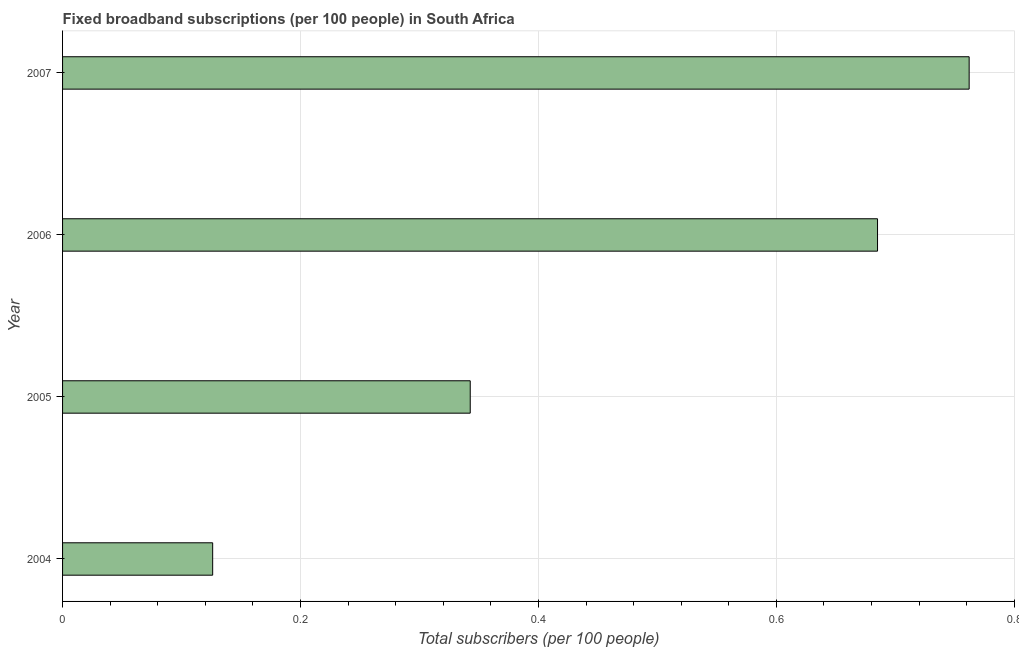Does the graph contain any zero values?
Make the answer very short. No. Does the graph contain grids?
Provide a short and direct response. Yes. What is the title of the graph?
Make the answer very short. Fixed broadband subscriptions (per 100 people) in South Africa. What is the label or title of the X-axis?
Give a very brief answer. Total subscribers (per 100 people). What is the total number of fixed broadband subscriptions in 2004?
Ensure brevity in your answer.  0.13. Across all years, what is the maximum total number of fixed broadband subscriptions?
Provide a short and direct response. 0.76. Across all years, what is the minimum total number of fixed broadband subscriptions?
Offer a very short reply. 0.13. In which year was the total number of fixed broadband subscriptions maximum?
Offer a very short reply. 2007. What is the sum of the total number of fixed broadband subscriptions?
Make the answer very short. 1.92. What is the difference between the total number of fixed broadband subscriptions in 2004 and 2007?
Give a very brief answer. -0.64. What is the average total number of fixed broadband subscriptions per year?
Provide a succinct answer. 0.48. What is the median total number of fixed broadband subscriptions?
Provide a short and direct response. 0.51. Do a majority of the years between 2006 and 2005 (inclusive) have total number of fixed broadband subscriptions greater than 0.08 ?
Offer a terse response. No. What is the ratio of the total number of fixed broadband subscriptions in 2005 to that in 2007?
Give a very brief answer. 0.45. Is the difference between the total number of fixed broadband subscriptions in 2004 and 2006 greater than the difference between any two years?
Keep it short and to the point. No. What is the difference between the highest and the second highest total number of fixed broadband subscriptions?
Provide a short and direct response. 0.08. Is the sum of the total number of fixed broadband subscriptions in 2005 and 2006 greater than the maximum total number of fixed broadband subscriptions across all years?
Give a very brief answer. Yes. What is the difference between the highest and the lowest total number of fixed broadband subscriptions?
Offer a terse response. 0.64. In how many years, is the total number of fixed broadband subscriptions greater than the average total number of fixed broadband subscriptions taken over all years?
Your answer should be compact. 2. How many bars are there?
Keep it short and to the point. 4. What is the difference between two consecutive major ticks on the X-axis?
Offer a very short reply. 0.2. What is the Total subscribers (per 100 people) of 2004?
Offer a terse response. 0.13. What is the Total subscribers (per 100 people) of 2005?
Your answer should be very brief. 0.34. What is the Total subscribers (per 100 people) of 2006?
Your response must be concise. 0.69. What is the Total subscribers (per 100 people) of 2007?
Your answer should be very brief. 0.76. What is the difference between the Total subscribers (per 100 people) in 2004 and 2005?
Offer a terse response. -0.22. What is the difference between the Total subscribers (per 100 people) in 2004 and 2006?
Ensure brevity in your answer.  -0.56. What is the difference between the Total subscribers (per 100 people) in 2004 and 2007?
Make the answer very short. -0.64. What is the difference between the Total subscribers (per 100 people) in 2005 and 2006?
Your answer should be very brief. -0.34. What is the difference between the Total subscribers (per 100 people) in 2005 and 2007?
Offer a very short reply. -0.42. What is the difference between the Total subscribers (per 100 people) in 2006 and 2007?
Offer a very short reply. -0.08. What is the ratio of the Total subscribers (per 100 people) in 2004 to that in 2005?
Offer a terse response. 0.37. What is the ratio of the Total subscribers (per 100 people) in 2004 to that in 2006?
Your response must be concise. 0.18. What is the ratio of the Total subscribers (per 100 people) in 2004 to that in 2007?
Your answer should be very brief. 0.17. What is the ratio of the Total subscribers (per 100 people) in 2005 to that in 2006?
Offer a very short reply. 0.5. What is the ratio of the Total subscribers (per 100 people) in 2005 to that in 2007?
Provide a succinct answer. 0.45. What is the ratio of the Total subscribers (per 100 people) in 2006 to that in 2007?
Your response must be concise. 0.9. 